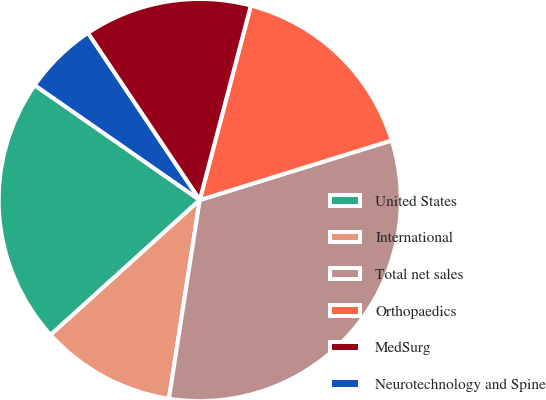Convert chart. <chart><loc_0><loc_0><loc_500><loc_500><pie_chart><fcel>United States<fcel>International<fcel>Total net sales<fcel>Orthopaedics<fcel>MedSurg<fcel>Neurotechnology and Spine<nl><fcel>21.38%<fcel>10.85%<fcel>32.24%<fcel>16.12%<fcel>13.48%<fcel>5.93%<nl></chart> 